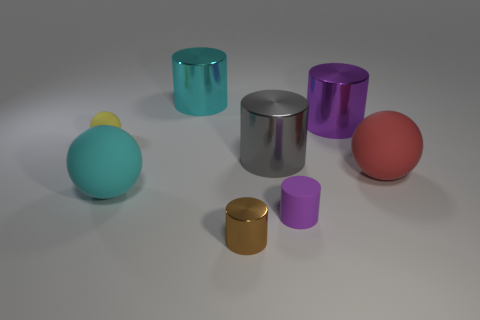Describe the color palette seen in the objects of the image. The image showcases a collection of objects featuring a soft, pastel-like color palette, encompassing muted shades of blue, red, and purple, alongside deeper tones of cyan and a vibrant gold. The matte and reflective surfaces of these objects add depth to the visual diversity. 